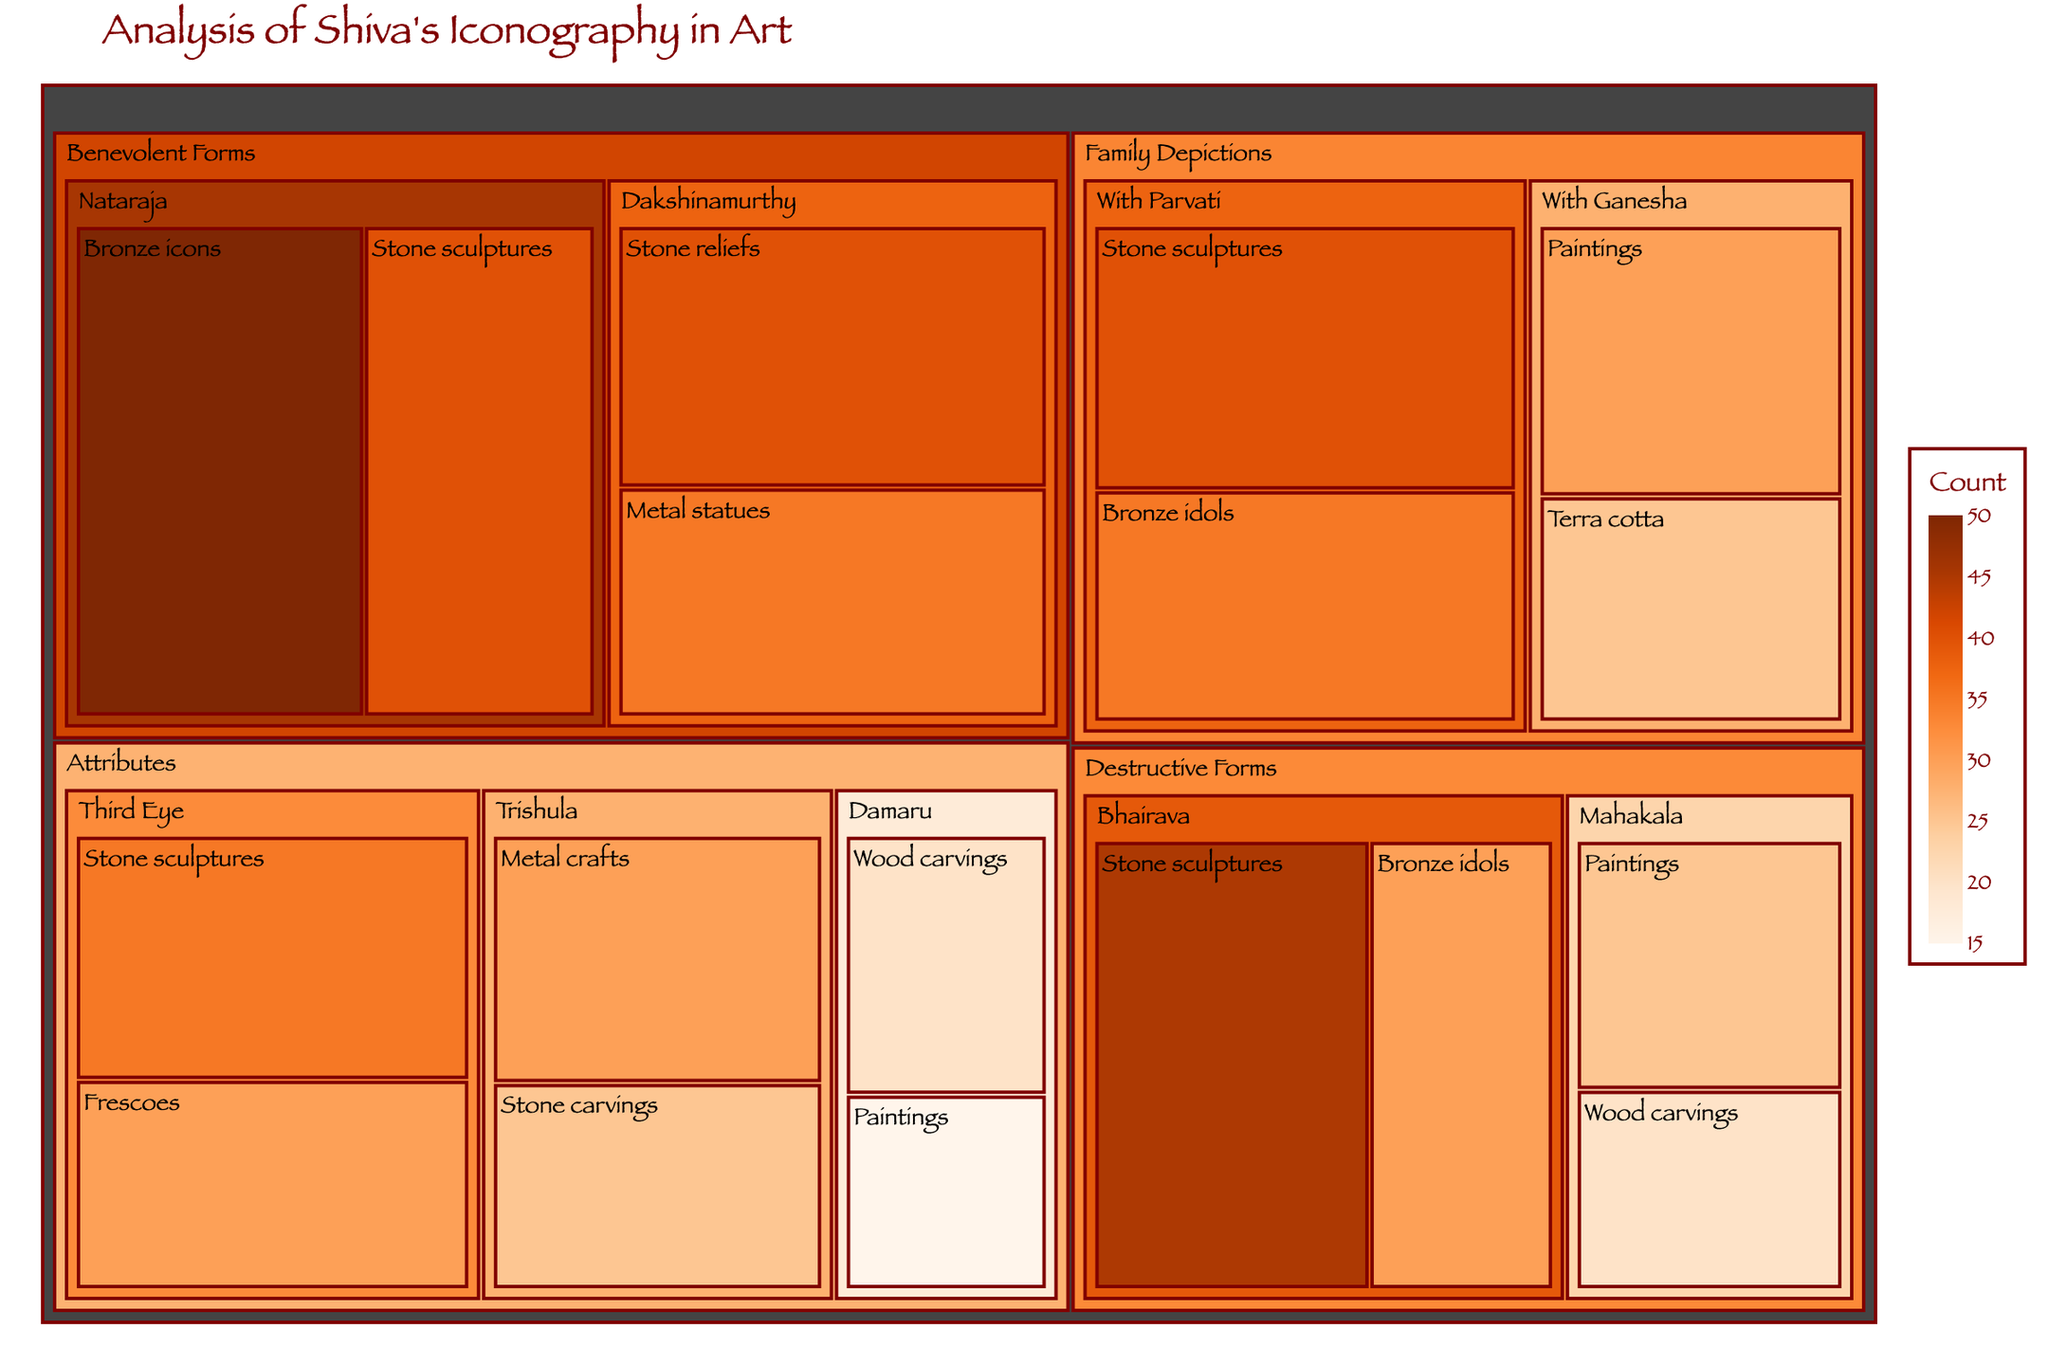what is the title of the treemap? The title of the treemap is displayed at the top center of the plot. It reads "Analysis of Shiva's Iconography in Art". This title is given to indicate the theme and subject matter of the treemap.
Answer: Analysis of Shiva's Iconography in Art Which subcategory under "Benevolent Forms" has the highest count? In the treemap, the counts for each subcategory under "Benevolent Forms" are visually represented. The subcategory with the highest count is indicated by the largest area. "Nataraja" has counts of 50 (Bronze icons) and 40 (Stone sculptures) which are higher compared to "Dakshinamurthy" with counts of 40 (Stone reliefs) and 35 (Metal statues).
Answer: Nataraja Among the attributes of Shiva, which has the highest representation in Stone sculptures? Within the Attributes category, to find which one has the highest count for Stone sculptures, look at the subcategories encompassing Stone sculptures and compare the values. The "Third Eye" attribute, with 35 Stone sculptures, is higher as compared to "Trishula" with 25 Stone sculptures.
Answer: Third Eye What is the total count of items in the "Destructive Forms" category? To calculate the total count of items in the "Destructive Forms" category, sum up the values from all subcategories: Bhairava (45 + 30) and Mahakala (25 + 20). Therefore, (45 + 30 + 25 + 20) = 120.
Answer: 120 How does the representation of "With Ganesha" in family depictions compare to "With Parvati" in terms of Paintings? "With Ganesha" in Paintings under family depictions has a count of 30, while "With Parvati" does not have a painting representation listed in the data.
Answer: 30 vs 0 Which material type is predominantly used in the depiction of the "Bhairava" form of Shiva? To determine the predominant material type, compare the counts of materials used for "Bhairava". Bronze idols (30) compared to Stone sculptures (45). Stone sculptures have the higher count.
Answer: Stone sculptures What is the difference in the count between metal and stone representations of the "Trishula" attribute? The count for Trishula in Metal crafts is 30 and in Stone carvings is 25. The difference is calculated as 30 - 25.
Answer: 5 How many items represent Shiva with family members in total? To find the total representation, sum the counts of items within "Family Depictions": With Parvati (40 Stone sculptures + 35 Bronze idols) and With Ganesha (30 Paintings + 25 Terra cotta). The total is (40 + 35 + 30 + 25) = 130.
Answer: 130 